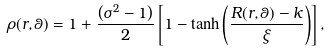Convert formula to latex. <formula><loc_0><loc_0><loc_500><loc_500>\rho ( r , \theta ) = 1 + \frac { \left ( \sigma ^ { 2 } - 1 \right ) } { 2 } \left [ 1 - \tanh \left ( \frac { R ( r , \theta ) - k } { \xi } \right ) \right ] ,</formula> 